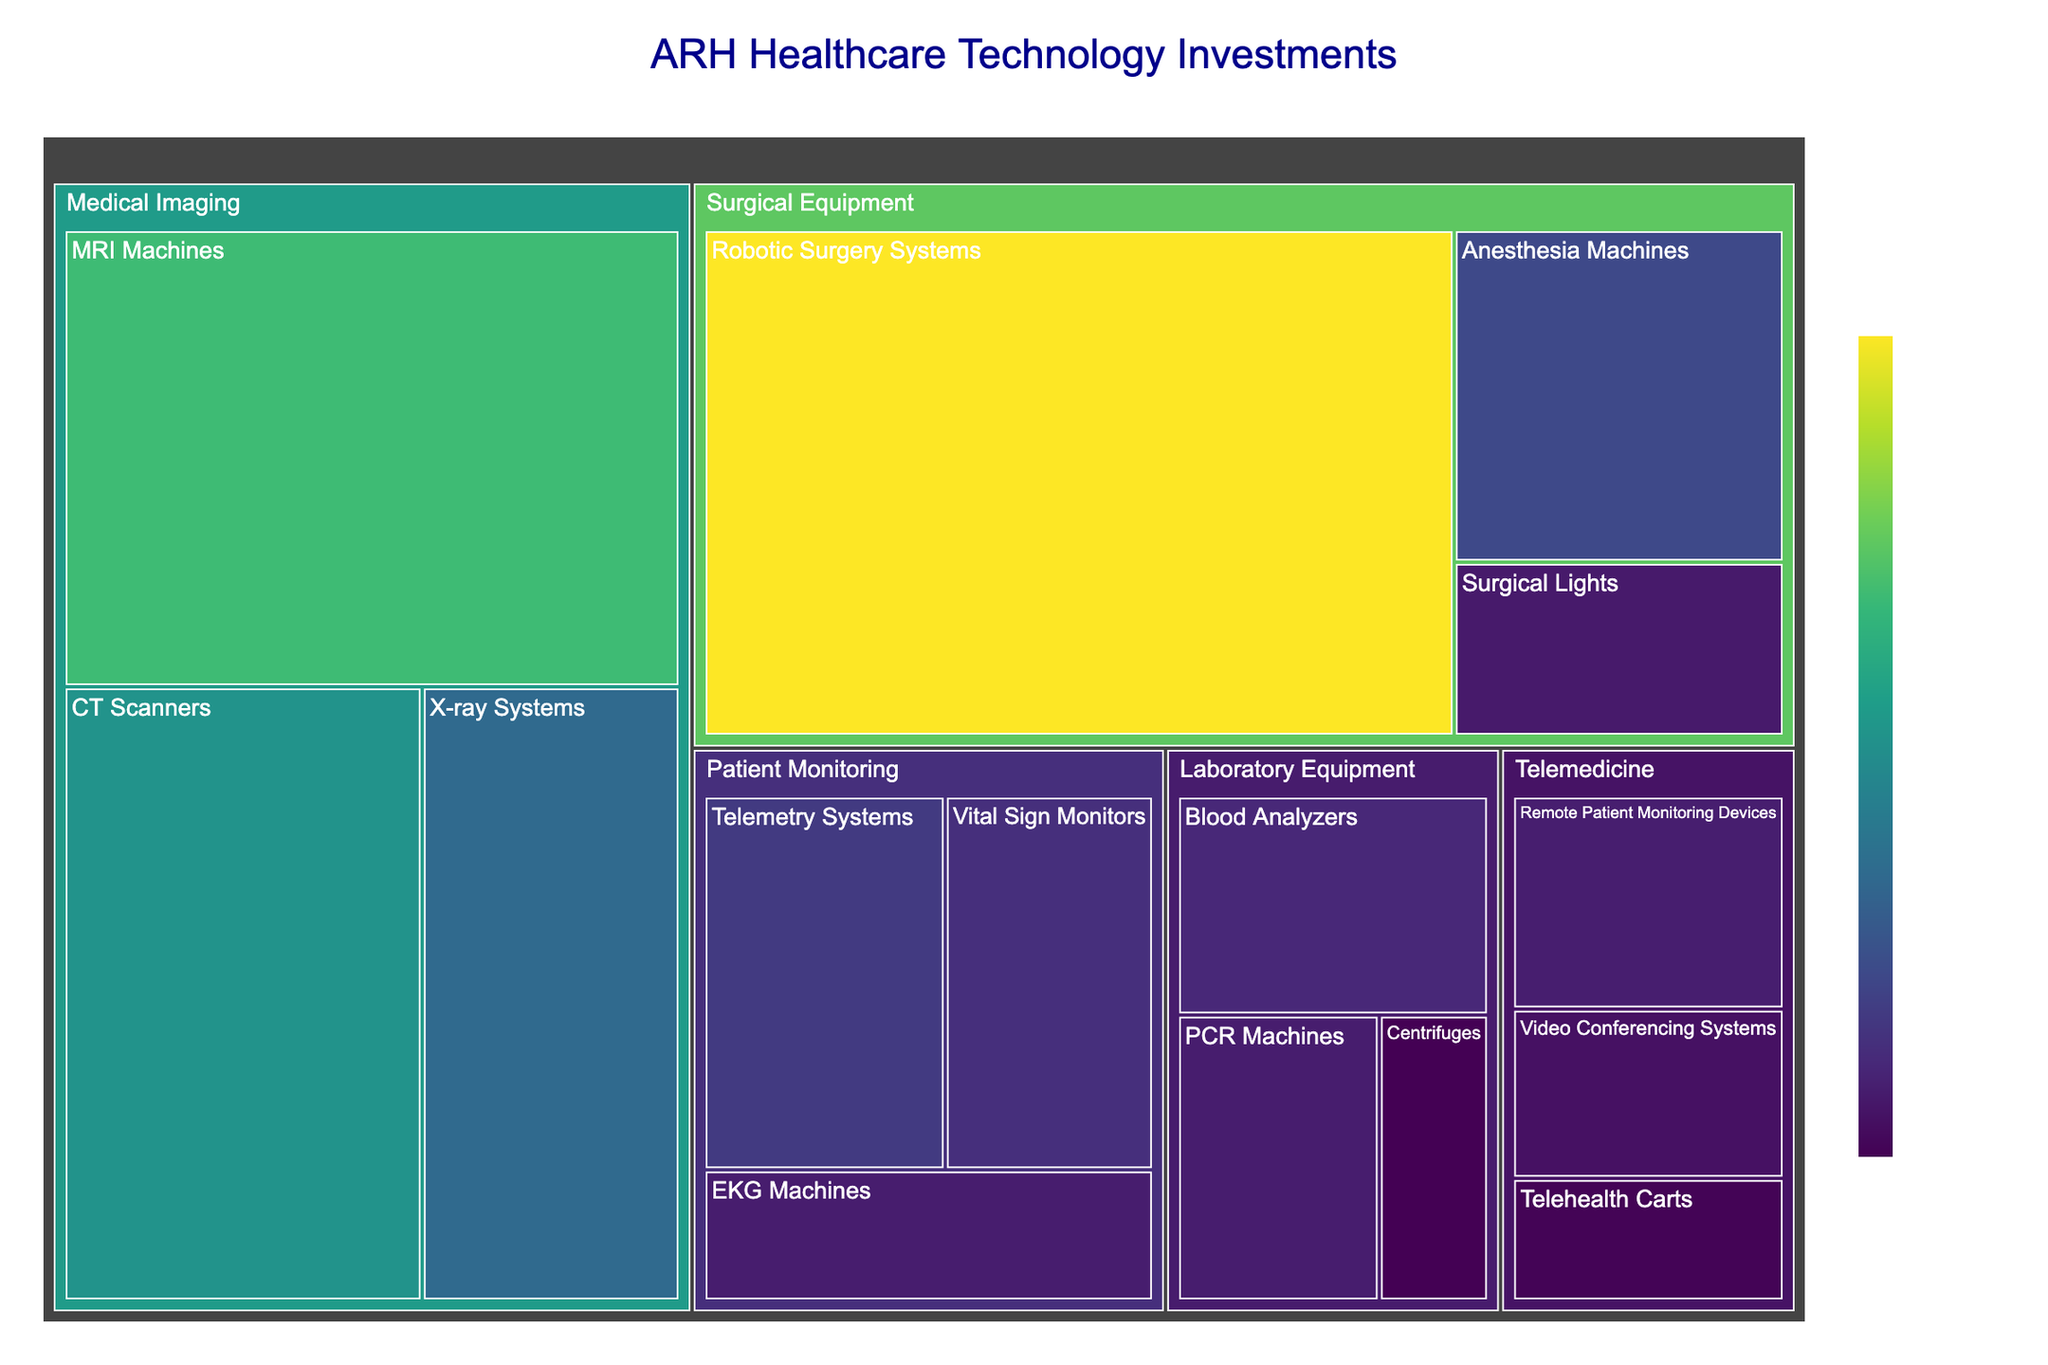what is the title of the treemap? The title of the treemap is centered at the top of the figure and is typically in a larger font size, colored dark blue.
Answer: ARH Healthcare Technology Investments How many subcategories are present under the category "Medical Imaging"? By inspecting the treemap, we see that the subcategories are visualized as rectangles nested under the main category "Medical Imaging". Count these rectangles.
Answer: 3 What is the monetary investment value for 'Surgical Lights'? Hovering over the 'Surgical Lights' subcategory will reveal the monetary investment value as a part of the hover data.
Answer: $680,000 Which category has the highest investment value? By examining the size and color intensity of the rectangles, the largest and darkest rectangle represents the highest investment category.
Answer: Surgical Equipment What is the total investment in the 'Telemedicine' category? Sum the values of all subcategories under 'Telemedicine': Video Conferencing Systems, Remote Patient Monitoring Devices, and Telehealth Carts. This is $580,000 + $730,000 + $420,000.
Answer: $1,730,000 Compare the investment between 'Anesthesia Machines' and 'Robotic Surgery Systems'. Which is greater and by how much? Compare the values shown for 'Anesthesia Machines' and 'Robotic Surgery Systems'. Subtract the smaller value from the larger value to find the difference.
Answer: Robotic Surgery Systems by $3,200,000 What percentage of the total investment does 'CT Scanners' represent? Sum all values to get the total investment. Divide the investment of 'CT Scanners' by this total and multiply by 100 to get the percentage.
Answer: 12.7% What is the combined investment value in 'Laboratory Equipment' and 'Patient Monitoring'? Sum the individual subcategory values in 'Laboratory Equipment' and 'Patient Monitoring'. For 'Laboratory Equipment': $850,000 + $720,000 + $390,000, and for 'Patient Monitoring': $950,000 + $720,000 + $1,100,000. Add these sums together.
Answer: $4,730,000 Which subcategory has the smallest investment within the 'Patient Monitoring' category? Inspect each subcategory under 'Patient Monitoring' and find the one with the smallest value.
Answer: EKG Machines By how much does the investment in 'MRI Machines' exceed that in 'CT Scanners'? Subtract the value of 'CT Scanners' from 'MRI Machines' to find out how much more is invested.
Answer: $700,000 